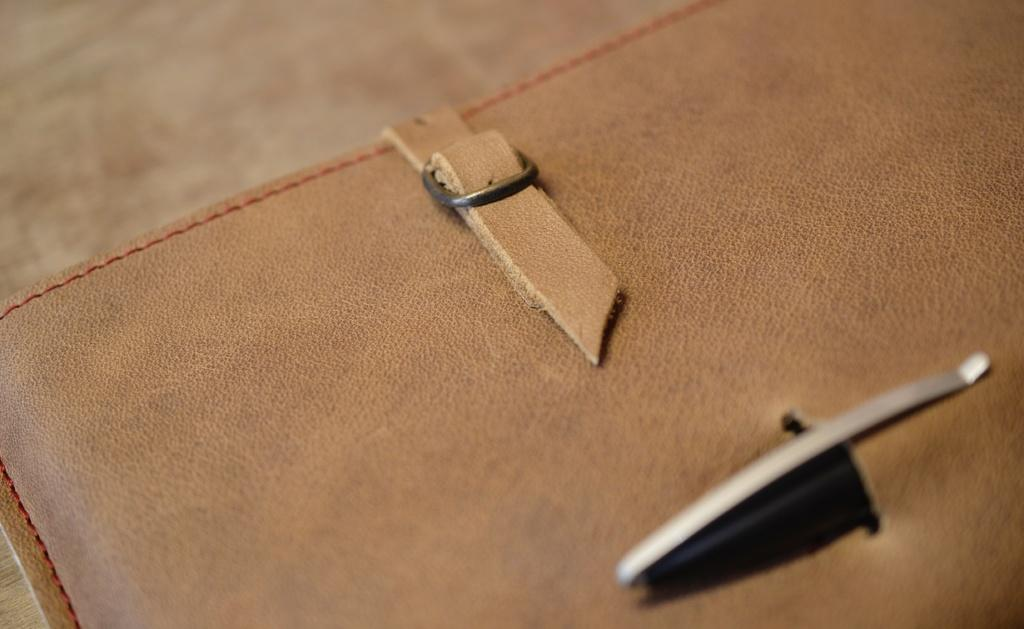What type of material is the main object in the image made of? The main object in the image is made of leather. Can you describe any specific features of the leather piece? Yes, the leather piece has stitches. What is the leather piece used for? The leather piece is associated with a belt. Are there any additional components attached to the leather piece? Yes, there is a steel pin attached to the leather piece. What type of baseball play is depicted in the image? There is no baseball play present in the image; it features a leather piece with stitches, a belt, and a steel pin. What act of kindness is shown in the image? There is no act of kindness depicted in the image; it focuses on a leather piece with stitches, a belt, and a steel pin. 